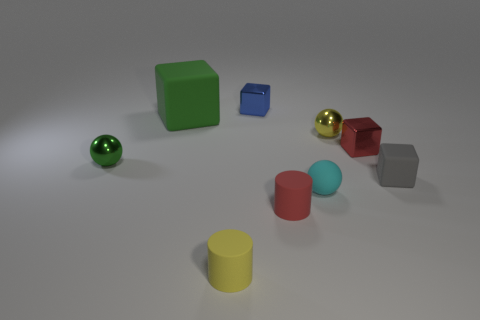Add 1 green matte cubes. How many objects exist? 10 Subtract all blocks. How many objects are left? 5 Subtract 0 gray spheres. How many objects are left? 9 Subtract all yellow cylinders. Subtract all small green matte cylinders. How many objects are left? 8 Add 4 blocks. How many blocks are left? 8 Add 5 tiny red matte things. How many tiny red matte things exist? 6 